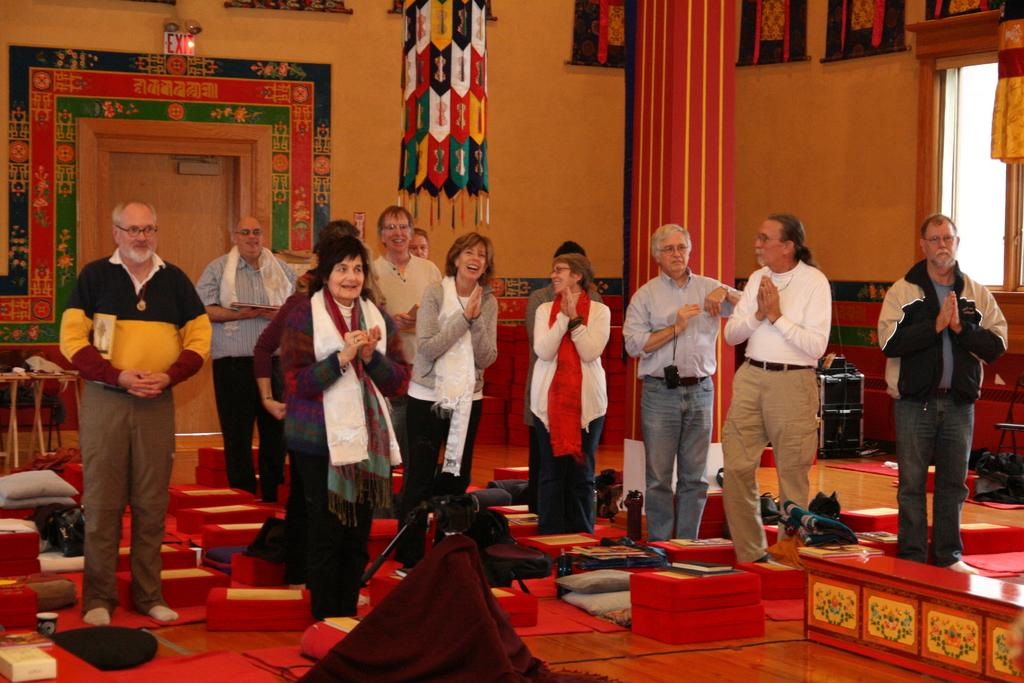Who or what is present in the image? There are people in the image. What objects can be seen in the image? There are boxes in the image. What type of structure is visible in the image? There is a wall in the image. What is used to hang items on the wall? Wall hangers are present in the image. What type of decorations are visible on the wall? Posters are visible in the image. Can you see any islands in the image? There are no islands present in the image. What type of plant is growing on the wall in the image? There are no plants visible in the image. 